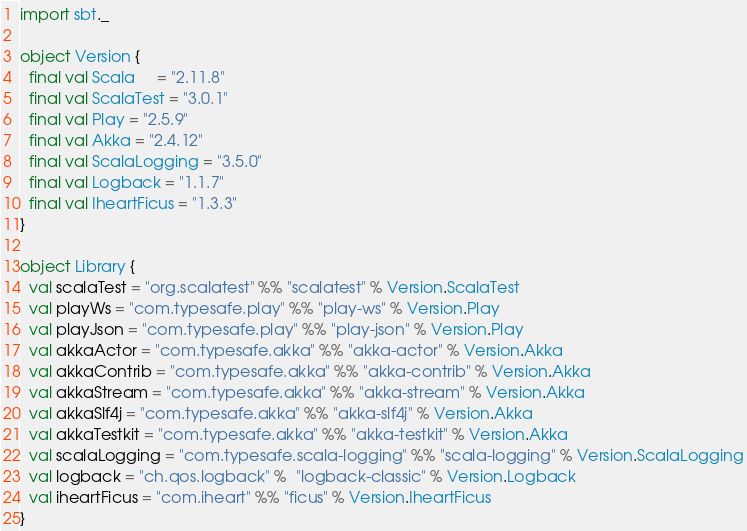<code> <loc_0><loc_0><loc_500><loc_500><_Scala_>import sbt._

object Version {
  final val Scala     = "2.11.8"
  final val ScalaTest = "3.0.1"
  final val Play = "2.5.9"
  final val Akka = "2.4.12"
  final val ScalaLogging = "3.5.0"
  final val Logback = "1.1.7"
  final val IheartFicus = "1.3.3"
}

object Library {
  val scalaTest = "org.scalatest" %% "scalatest" % Version.ScalaTest
  val playWs = "com.typesafe.play" %% "play-ws" % Version.Play
  val playJson = "com.typesafe.play" %% "play-json" % Version.Play
  val akkaActor = "com.typesafe.akka" %% "akka-actor" % Version.Akka
  val akkaContrib = "com.typesafe.akka" %% "akka-contrib" % Version.Akka
  val akkaStream = "com.typesafe.akka" %% "akka-stream" % Version.Akka
  val akkaSlf4j = "com.typesafe.akka" %% "akka-slf4j" % Version.Akka
  val akkaTestkit = "com.typesafe.akka" %% "akka-testkit" % Version.Akka
  val scalaLogging = "com.typesafe.scala-logging" %% "scala-logging" % Version.ScalaLogging
  val logback = "ch.qos.logback" %  "logback-classic" % Version.Logback
  val iheartFicus = "com.iheart" %% "ficus" % Version.IheartFicus
}
</code> 